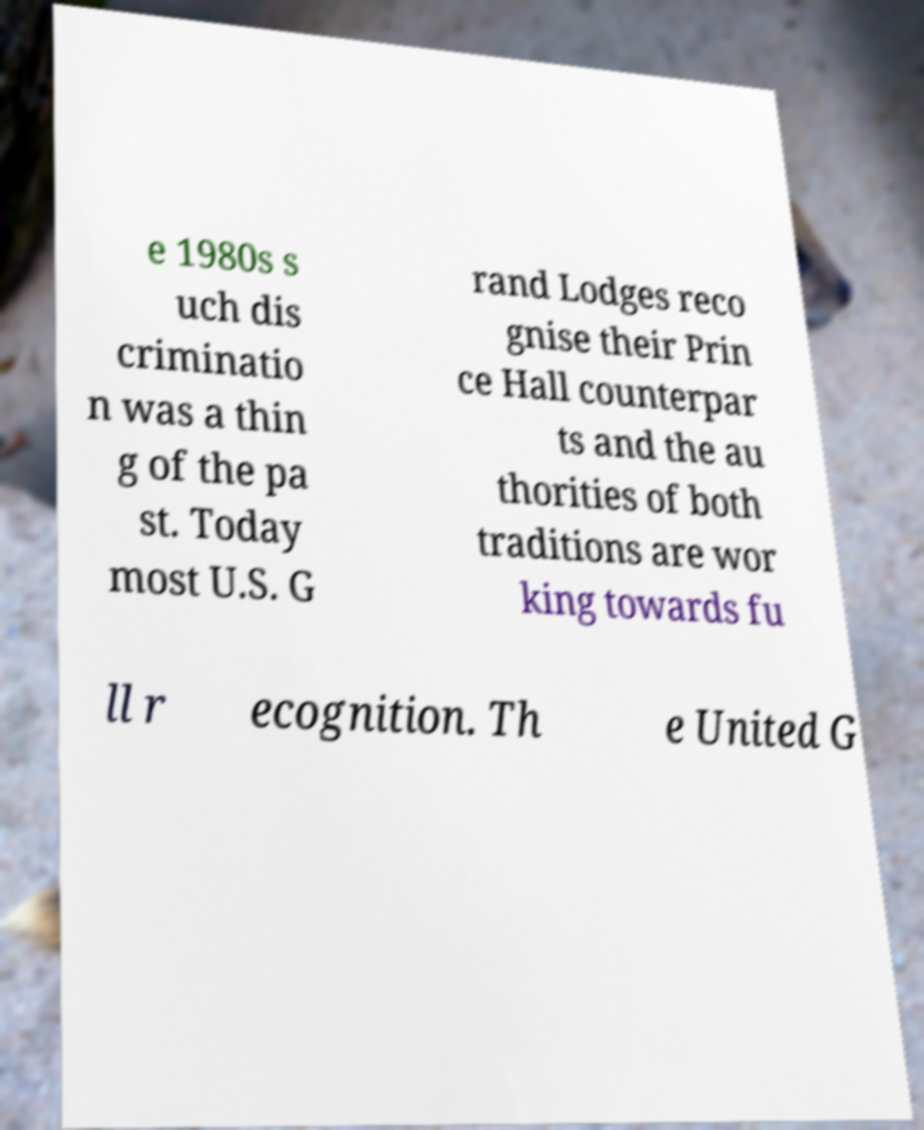Can you accurately transcribe the text from the provided image for me? e 1980s s uch dis criminatio n was a thin g of the pa st. Today most U.S. G rand Lodges reco gnise their Prin ce Hall counterpar ts and the au thorities of both traditions are wor king towards fu ll r ecognition. Th e United G 